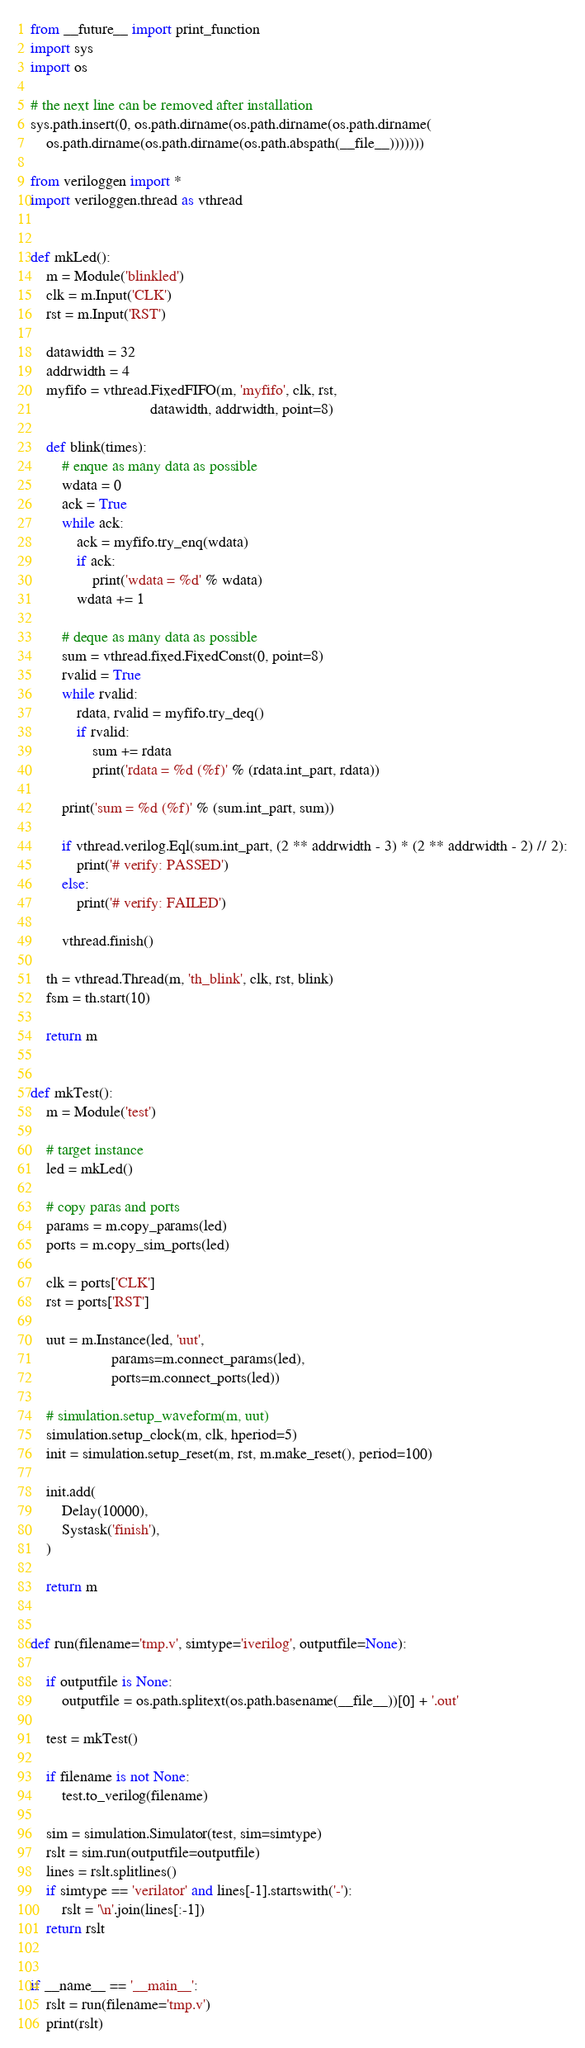<code> <loc_0><loc_0><loc_500><loc_500><_Python_>from __future__ import print_function
import sys
import os

# the next line can be removed after installation
sys.path.insert(0, os.path.dirname(os.path.dirname(os.path.dirname(
    os.path.dirname(os.path.dirname(os.path.abspath(__file__)))))))

from veriloggen import *
import veriloggen.thread as vthread


def mkLed():
    m = Module('blinkled')
    clk = m.Input('CLK')
    rst = m.Input('RST')

    datawidth = 32
    addrwidth = 4
    myfifo = vthread.FixedFIFO(m, 'myfifo', clk, rst,
                               datawidth, addrwidth, point=8)

    def blink(times):
        # enque as many data as possible
        wdata = 0
        ack = True
        while ack:
            ack = myfifo.try_enq(wdata)
            if ack:
                print('wdata = %d' % wdata)
            wdata += 1

        # deque as many data as possible
        sum = vthread.fixed.FixedConst(0, point=8)
        rvalid = True
        while rvalid:
            rdata, rvalid = myfifo.try_deq()
            if rvalid:
                sum += rdata
                print('rdata = %d (%f)' % (rdata.int_part, rdata))

        print('sum = %d (%f)' % (sum.int_part, sum))

        if vthread.verilog.Eql(sum.int_part, (2 ** addrwidth - 3) * (2 ** addrwidth - 2) // 2):
            print('# verify: PASSED')
        else:
            print('# verify: FAILED')

        vthread.finish()

    th = vthread.Thread(m, 'th_blink', clk, rst, blink)
    fsm = th.start(10)

    return m


def mkTest():
    m = Module('test')

    # target instance
    led = mkLed()

    # copy paras and ports
    params = m.copy_params(led)
    ports = m.copy_sim_ports(led)

    clk = ports['CLK']
    rst = ports['RST']

    uut = m.Instance(led, 'uut',
                     params=m.connect_params(led),
                     ports=m.connect_ports(led))

    # simulation.setup_waveform(m, uut)
    simulation.setup_clock(m, clk, hperiod=5)
    init = simulation.setup_reset(m, rst, m.make_reset(), period=100)

    init.add(
        Delay(10000),
        Systask('finish'),
    )

    return m


def run(filename='tmp.v', simtype='iverilog', outputfile=None):

    if outputfile is None:
        outputfile = os.path.splitext(os.path.basename(__file__))[0] + '.out'

    test = mkTest()

    if filename is not None:
        test.to_verilog(filename)

    sim = simulation.Simulator(test, sim=simtype)
    rslt = sim.run(outputfile=outputfile)
    lines = rslt.splitlines()
    if simtype == 'verilator' and lines[-1].startswith('-'):
        rslt = '\n'.join(lines[:-1])
    return rslt


if __name__ == '__main__':
    rslt = run(filename='tmp.v')
    print(rslt)
</code> 